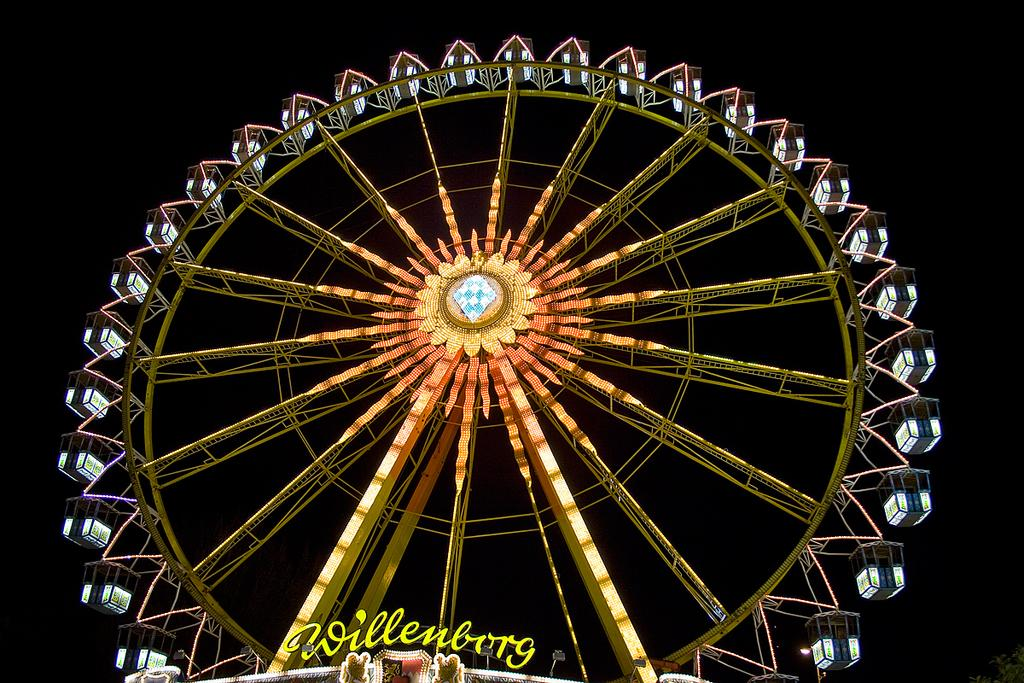What is the main subject of the picture? The main subject of the picture is a giant wheel. What other object is present in the image? There is an LED board in the picture. What color is the LED board? The LED board is yellow in color. How would you describe the background of the image? The background of the image is dark. What type of celery is being used to connect the giant wheel to the LED board in the image? There is no celery present in the image, nor is it being used to connect the giant wheel to the LED board. 